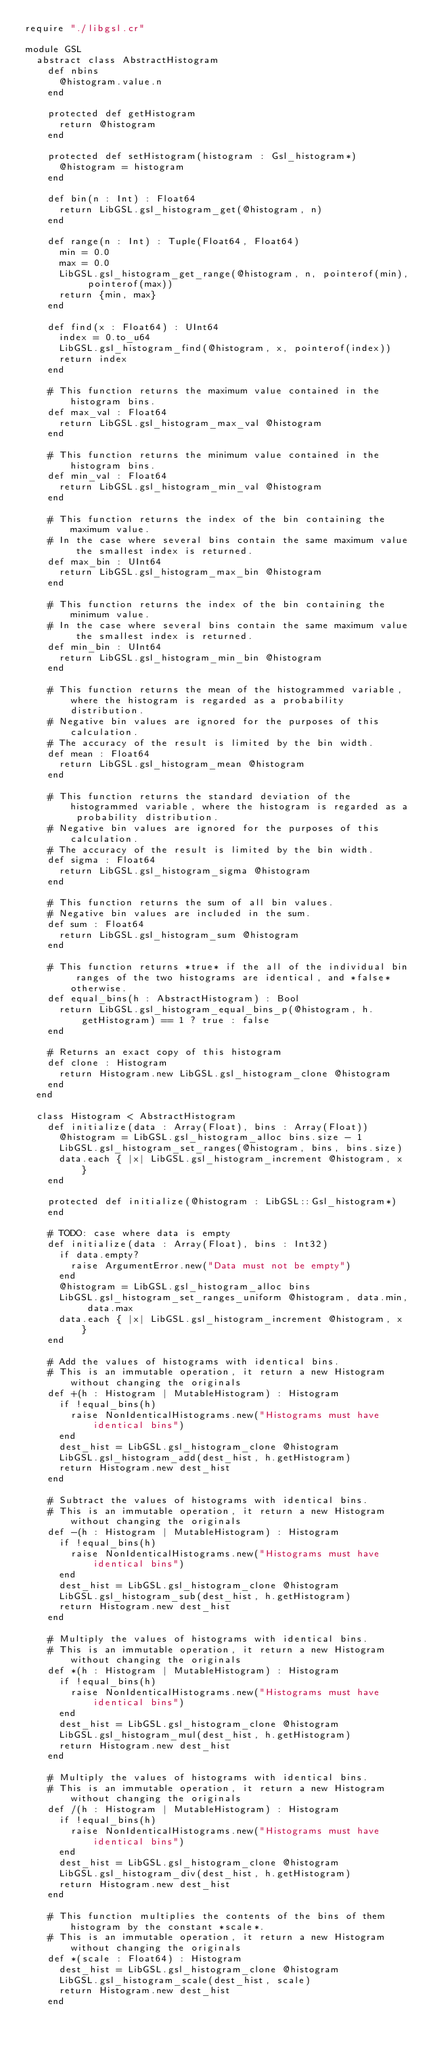<code> <loc_0><loc_0><loc_500><loc_500><_Crystal_>require "./libgsl.cr"

module GSL
  abstract class AbstractHistogram
    def nbins
      @histogram.value.n
    end

    protected def getHistogram
      return @histogram
    end

    protected def setHistogram(histogram : Gsl_histogram*)
      @histogram = histogram
    end

    def bin(n : Int) : Float64
      return LibGSL.gsl_histogram_get(@histogram, n)
    end

    def range(n : Int) : Tuple(Float64, Float64)
      min = 0.0
      max = 0.0
      LibGSL.gsl_histogram_get_range(@histogram, n, pointerof(min), pointerof(max))
      return {min, max}
    end

    def find(x : Float64) : UInt64
      index = 0.to_u64
      LibGSL.gsl_histogram_find(@histogram, x, pointerof(index))
      return index
    end

    # This function returns the maximum value contained in the histogram bins.
    def max_val : Float64
      return LibGSL.gsl_histogram_max_val @histogram
    end

    # This function returns the minimum value contained in the histogram bins.
    def min_val : Float64
      return LibGSL.gsl_histogram_min_val @histogram
    end

    # This function returns the index of the bin containing the maximum value.
    # In the case where several bins contain the same maximum value the smallest index is returned.
    def max_bin : UInt64
      return LibGSL.gsl_histogram_max_bin @histogram
    end

    # This function returns the index of the bin containing the minimum value.
    # In the case where several bins contain the same maximum value the smallest index is returned.
    def min_bin : UInt64
      return LibGSL.gsl_histogram_min_bin @histogram
    end

    # This function returns the mean of the histogrammed variable, where the histogram is regarded as a probability distribution.
    # Negative bin values are ignored for the purposes of this calculation.
    # The accuracy of the result is limited by the bin width.
    def mean : Float64
      return LibGSL.gsl_histogram_mean @histogram
    end

    # This function returns the standard deviation of the histogrammed variable, where the histogram is regarded as a probability distribution.
    # Negative bin values are ignored for the purposes of this calculation.
    # The accuracy of the result is limited by the bin width.
    def sigma : Float64
      return LibGSL.gsl_histogram_sigma @histogram
    end

    # This function returns the sum of all bin values.
    # Negative bin values are included in the sum.
    def sum : Float64
      return LibGSL.gsl_histogram_sum @histogram
    end

    # This function returns *true* if the all of the individual bin ranges of the two histograms are identical, and *false* otherwise.
    def equal_bins(h : AbstractHistogram) : Bool
      return LibGSL.gsl_histogram_equal_bins_p(@histogram, h.getHistogram) == 1 ? true : false
    end

    # Returns an exact copy of this histogram
    def clone : Histogram
      return Histogram.new LibGSL.gsl_histogram_clone @histogram
    end
  end

  class Histogram < AbstractHistogram
    def initialize(data : Array(Float), bins : Array(Float))
      @histogram = LibGSL.gsl_histogram_alloc bins.size - 1
      LibGSL.gsl_histogram_set_ranges(@histogram, bins, bins.size)
      data.each { |x| LibGSL.gsl_histogram_increment @histogram, x }
    end

    protected def initialize(@histogram : LibGSL::Gsl_histogram*)
    end

    # TODO: case where data is empty
    def initialize(data : Array(Float), bins : Int32)
      if data.empty?
        raise ArgumentError.new("Data must not be empty")
      end
      @histogram = LibGSL.gsl_histogram_alloc bins
      LibGSL.gsl_histogram_set_ranges_uniform @histogram, data.min, data.max
      data.each { |x| LibGSL.gsl_histogram_increment @histogram, x }
    end

    # Add the values of histograms with identical bins.
    # This is an immutable operation, it return a new Histogram without changing the originals
    def +(h : Histogram | MutableHistogram) : Histogram
      if !equal_bins(h)
        raise NonIdenticalHistograms.new("Histograms must have identical bins")
      end
      dest_hist = LibGSL.gsl_histogram_clone @histogram
      LibGSL.gsl_histogram_add(dest_hist, h.getHistogram)
      return Histogram.new dest_hist
    end

    # Subtract the values of histograms with identical bins.
    # This is an immutable operation, it return a new Histogram without changing the originals
    def -(h : Histogram | MutableHistogram) : Histogram
      if !equal_bins(h)
        raise NonIdenticalHistograms.new("Histograms must have identical bins")
      end
      dest_hist = LibGSL.gsl_histogram_clone @histogram
      LibGSL.gsl_histogram_sub(dest_hist, h.getHistogram)
      return Histogram.new dest_hist
    end

    # Multiply the values of histograms with identical bins.
    # This is an immutable operation, it return a new Histogram without changing the originals
    def *(h : Histogram | MutableHistogram) : Histogram
      if !equal_bins(h)
        raise NonIdenticalHistograms.new("Histograms must have identical bins")
      end
      dest_hist = LibGSL.gsl_histogram_clone @histogram
      LibGSL.gsl_histogram_mul(dest_hist, h.getHistogram)
      return Histogram.new dest_hist
    end

    # Multiply the values of histograms with identical bins.
    # This is an immutable operation, it return a new Histogram without changing the originals
    def /(h : Histogram | MutableHistogram) : Histogram
      if !equal_bins(h)
        raise NonIdenticalHistograms.new("Histograms must have identical bins")
      end
      dest_hist = LibGSL.gsl_histogram_clone @histogram
      LibGSL.gsl_histogram_div(dest_hist, h.getHistogram)
      return Histogram.new dest_hist
    end

    # This function multiplies the contents of the bins of them histogram by the constant *scale*.
    # This is an immutable operation, it return a new Histogram without changing the originals
    def *(scale : Float64) : Histogram
      dest_hist = LibGSL.gsl_histogram_clone @histogram
      LibGSL.gsl_histogram_scale(dest_hist, scale)
      return Histogram.new dest_hist
    end
</code> 